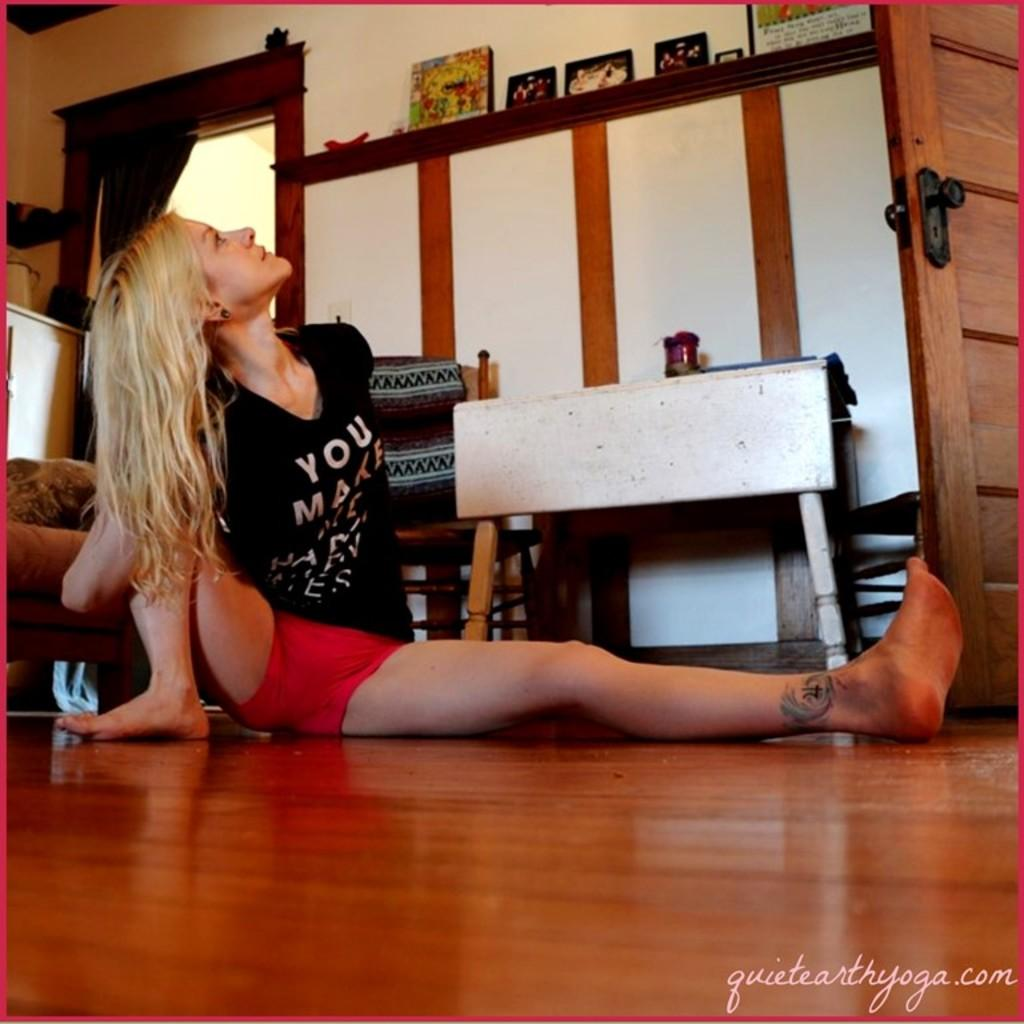<image>
Create a compact narrative representing the image presented. A woman stretching on the floor has a shirt that has the word YOU on it. 